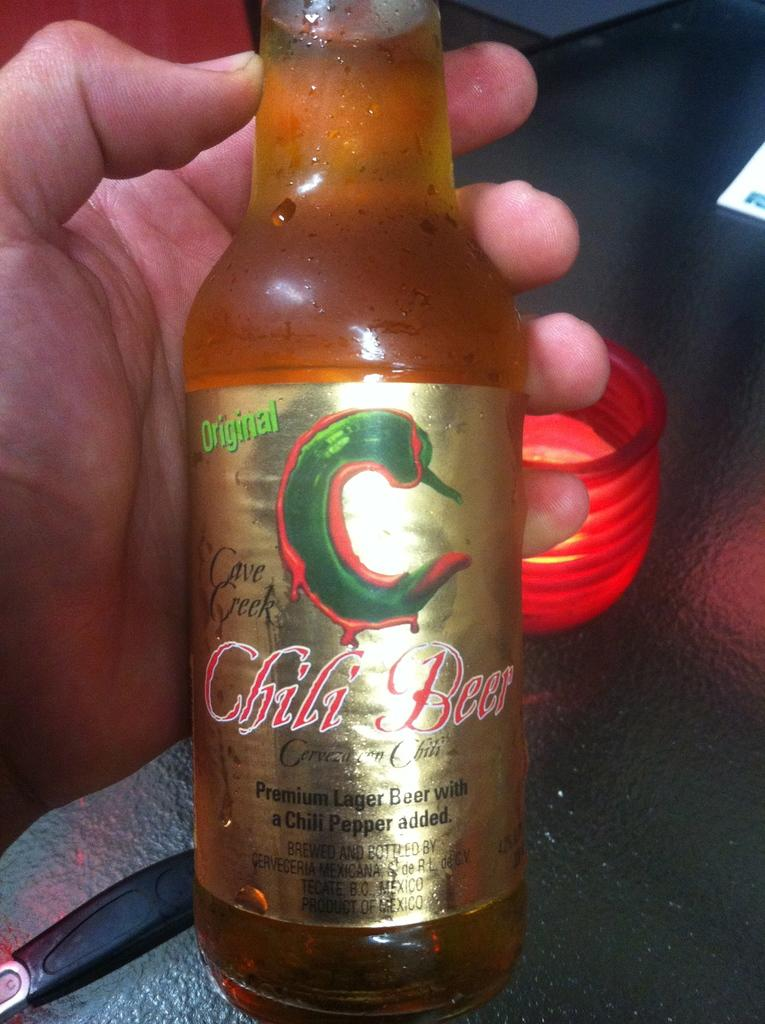<image>
Give a short and clear explanation of the subsequent image. Person holding a bottle of Chili Beer with a picture of a chili on the label. 